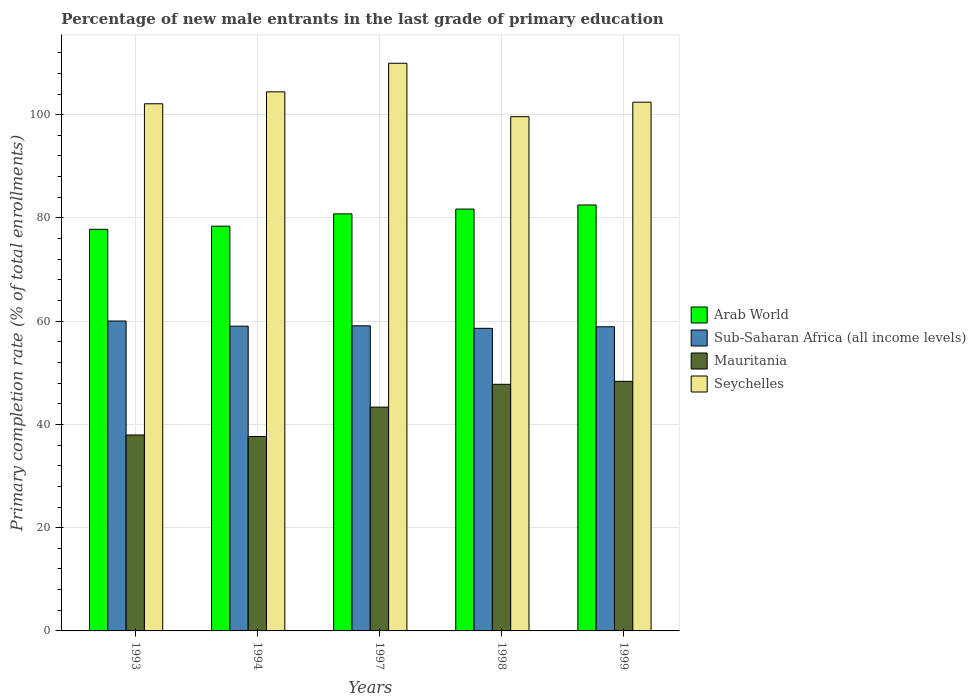How many different coloured bars are there?
Your answer should be very brief. 4. How many groups of bars are there?
Give a very brief answer. 5. Are the number of bars on each tick of the X-axis equal?
Ensure brevity in your answer.  Yes. In how many cases, is the number of bars for a given year not equal to the number of legend labels?
Your answer should be compact. 0. What is the percentage of new male entrants in Sub-Saharan Africa (all income levels) in 1994?
Keep it short and to the point. 59.03. Across all years, what is the maximum percentage of new male entrants in Sub-Saharan Africa (all income levels)?
Your answer should be compact. 60.03. Across all years, what is the minimum percentage of new male entrants in Arab World?
Your answer should be very brief. 77.8. In which year was the percentage of new male entrants in Seychelles maximum?
Ensure brevity in your answer.  1997. In which year was the percentage of new male entrants in Mauritania minimum?
Your response must be concise. 1994. What is the total percentage of new male entrants in Seychelles in the graph?
Keep it short and to the point. 518.54. What is the difference between the percentage of new male entrants in Seychelles in 1993 and that in 1998?
Offer a terse response. 2.5. What is the difference between the percentage of new male entrants in Arab World in 1997 and the percentage of new male entrants in Seychelles in 1999?
Give a very brief answer. -21.63. What is the average percentage of new male entrants in Mauritania per year?
Your answer should be very brief. 43.02. In the year 1999, what is the difference between the percentage of new male entrants in Sub-Saharan Africa (all income levels) and percentage of new male entrants in Mauritania?
Offer a very short reply. 10.57. In how many years, is the percentage of new male entrants in Sub-Saharan Africa (all income levels) greater than 108 %?
Make the answer very short. 0. What is the ratio of the percentage of new male entrants in Mauritania in 1993 to that in 1999?
Your answer should be compact. 0.79. Is the percentage of new male entrants in Arab World in 1993 less than that in 1997?
Offer a terse response. Yes. Is the difference between the percentage of new male entrants in Sub-Saharan Africa (all income levels) in 1993 and 1999 greater than the difference between the percentage of new male entrants in Mauritania in 1993 and 1999?
Offer a terse response. Yes. What is the difference between the highest and the second highest percentage of new male entrants in Seychelles?
Give a very brief answer. 5.54. What is the difference between the highest and the lowest percentage of new male entrants in Sub-Saharan Africa (all income levels)?
Offer a very short reply. 1.42. In how many years, is the percentage of new male entrants in Arab World greater than the average percentage of new male entrants in Arab World taken over all years?
Your answer should be very brief. 3. Is it the case that in every year, the sum of the percentage of new male entrants in Sub-Saharan Africa (all income levels) and percentage of new male entrants in Arab World is greater than the sum of percentage of new male entrants in Mauritania and percentage of new male entrants in Seychelles?
Provide a short and direct response. Yes. What does the 1st bar from the left in 1998 represents?
Offer a terse response. Arab World. What does the 4th bar from the right in 1994 represents?
Your answer should be very brief. Arab World. How many bars are there?
Your answer should be compact. 20. Are all the bars in the graph horizontal?
Give a very brief answer. No. How many years are there in the graph?
Your answer should be very brief. 5. What is the difference between two consecutive major ticks on the Y-axis?
Keep it short and to the point. 20. Are the values on the major ticks of Y-axis written in scientific E-notation?
Keep it short and to the point. No. Does the graph contain grids?
Provide a succinct answer. Yes. Where does the legend appear in the graph?
Keep it short and to the point. Center right. How many legend labels are there?
Provide a short and direct response. 4. What is the title of the graph?
Keep it short and to the point. Percentage of new male entrants in the last grade of primary education. What is the label or title of the Y-axis?
Ensure brevity in your answer.  Primary completion rate (% of total enrollments). What is the Primary completion rate (% of total enrollments) of Arab World in 1993?
Your response must be concise. 77.8. What is the Primary completion rate (% of total enrollments) of Sub-Saharan Africa (all income levels) in 1993?
Offer a terse response. 60.03. What is the Primary completion rate (% of total enrollments) of Mauritania in 1993?
Ensure brevity in your answer.  37.96. What is the Primary completion rate (% of total enrollments) in Seychelles in 1993?
Your answer should be compact. 102.11. What is the Primary completion rate (% of total enrollments) in Arab World in 1994?
Give a very brief answer. 78.4. What is the Primary completion rate (% of total enrollments) in Sub-Saharan Africa (all income levels) in 1994?
Ensure brevity in your answer.  59.03. What is the Primary completion rate (% of total enrollments) in Mauritania in 1994?
Provide a short and direct response. 37.66. What is the Primary completion rate (% of total enrollments) in Seychelles in 1994?
Your answer should be very brief. 104.42. What is the Primary completion rate (% of total enrollments) of Arab World in 1997?
Ensure brevity in your answer.  80.79. What is the Primary completion rate (% of total enrollments) in Sub-Saharan Africa (all income levels) in 1997?
Your answer should be very brief. 59.1. What is the Primary completion rate (% of total enrollments) in Mauritania in 1997?
Keep it short and to the point. 43.35. What is the Primary completion rate (% of total enrollments) of Seychelles in 1997?
Provide a succinct answer. 109.96. What is the Primary completion rate (% of total enrollments) in Arab World in 1998?
Keep it short and to the point. 81.72. What is the Primary completion rate (% of total enrollments) of Sub-Saharan Africa (all income levels) in 1998?
Offer a terse response. 58.61. What is the Primary completion rate (% of total enrollments) in Mauritania in 1998?
Your response must be concise. 47.77. What is the Primary completion rate (% of total enrollments) of Seychelles in 1998?
Your response must be concise. 99.61. What is the Primary completion rate (% of total enrollments) of Arab World in 1999?
Provide a succinct answer. 82.51. What is the Primary completion rate (% of total enrollments) of Sub-Saharan Africa (all income levels) in 1999?
Offer a very short reply. 58.92. What is the Primary completion rate (% of total enrollments) of Mauritania in 1999?
Keep it short and to the point. 48.35. What is the Primary completion rate (% of total enrollments) in Seychelles in 1999?
Offer a very short reply. 102.42. Across all years, what is the maximum Primary completion rate (% of total enrollments) in Arab World?
Your answer should be compact. 82.51. Across all years, what is the maximum Primary completion rate (% of total enrollments) of Sub-Saharan Africa (all income levels)?
Offer a very short reply. 60.03. Across all years, what is the maximum Primary completion rate (% of total enrollments) in Mauritania?
Your response must be concise. 48.35. Across all years, what is the maximum Primary completion rate (% of total enrollments) in Seychelles?
Your answer should be compact. 109.96. Across all years, what is the minimum Primary completion rate (% of total enrollments) of Arab World?
Ensure brevity in your answer.  77.8. Across all years, what is the minimum Primary completion rate (% of total enrollments) of Sub-Saharan Africa (all income levels)?
Ensure brevity in your answer.  58.61. Across all years, what is the minimum Primary completion rate (% of total enrollments) of Mauritania?
Provide a short and direct response. 37.66. Across all years, what is the minimum Primary completion rate (% of total enrollments) of Seychelles?
Keep it short and to the point. 99.61. What is the total Primary completion rate (% of total enrollments) of Arab World in the graph?
Your answer should be very brief. 401.21. What is the total Primary completion rate (% of total enrollments) in Sub-Saharan Africa (all income levels) in the graph?
Provide a succinct answer. 295.7. What is the total Primary completion rate (% of total enrollments) in Mauritania in the graph?
Offer a very short reply. 215.09. What is the total Primary completion rate (% of total enrollments) in Seychelles in the graph?
Provide a short and direct response. 518.54. What is the difference between the Primary completion rate (% of total enrollments) in Arab World in 1993 and that in 1994?
Make the answer very short. -0.61. What is the difference between the Primary completion rate (% of total enrollments) in Sub-Saharan Africa (all income levels) in 1993 and that in 1994?
Offer a terse response. 1. What is the difference between the Primary completion rate (% of total enrollments) of Mauritania in 1993 and that in 1994?
Offer a terse response. 0.29. What is the difference between the Primary completion rate (% of total enrollments) of Seychelles in 1993 and that in 1994?
Offer a very short reply. -2.31. What is the difference between the Primary completion rate (% of total enrollments) in Arab World in 1993 and that in 1997?
Provide a short and direct response. -2.99. What is the difference between the Primary completion rate (% of total enrollments) in Sub-Saharan Africa (all income levels) in 1993 and that in 1997?
Offer a very short reply. 0.93. What is the difference between the Primary completion rate (% of total enrollments) in Mauritania in 1993 and that in 1997?
Your answer should be very brief. -5.39. What is the difference between the Primary completion rate (% of total enrollments) of Seychelles in 1993 and that in 1997?
Offer a terse response. -7.85. What is the difference between the Primary completion rate (% of total enrollments) in Arab World in 1993 and that in 1998?
Offer a terse response. -3.92. What is the difference between the Primary completion rate (% of total enrollments) in Sub-Saharan Africa (all income levels) in 1993 and that in 1998?
Give a very brief answer. 1.42. What is the difference between the Primary completion rate (% of total enrollments) of Mauritania in 1993 and that in 1998?
Your answer should be compact. -9.82. What is the difference between the Primary completion rate (% of total enrollments) in Arab World in 1993 and that in 1999?
Your answer should be compact. -4.71. What is the difference between the Primary completion rate (% of total enrollments) of Sub-Saharan Africa (all income levels) in 1993 and that in 1999?
Make the answer very short. 1.11. What is the difference between the Primary completion rate (% of total enrollments) of Mauritania in 1993 and that in 1999?
Offer a very short reply. -10.39. What is the difference between the Primary completion rate (% of total enrollments) of Seychelles in 1993 and that in 1999?
Give a very brief answer. -0.31. What is the difference between the Primary completion rate (% of total enrollments) in Arab World in 1994 and that in 1997?
Provide a succinct answer. -2.38. What is the difference between the Primary completion rate (% of total enrollments) of Sub-Saharan Africa (all income levels) in 1994 and that in 1997?
Make the answer very short. -0.07. What is the difference between the Primary completion rate (% of total enrollments) of Mauritania in 1994 and that in 1997?
Offer a very short reply. -5.68. What is the difference between the Primary completion rate (% of total enrollments) of Seychelles in 1994 and that in 1997?
Make the answer very short. -5.54. What is the difference between the Primary completion rate (% of total enrollments) of Arab World in 1994 and that in 1998?
Ensure brevity in your answer.  -3.31. What is the difference between the Primary completion rate (% of total enrollments) of Sub-Saharan Africa (all income levels) in 1994 and that in 1998?
Provide a succinct answer. 0.42. What is the difference between the Primary completion rate (% of total enrollments) in Mauritania in 1994 and that in 1998?
Keep it short and to the point. -10.11. What is the difference between the Primary completion rate (% of total enrollments) of Seychelles in 1994 and that in 1998?
Give a very brief answer. 4.81. What is the difference between the Primary completion rate (% of total enrollments) in Arab World in 1994 and that in 1999?
Provide a short and direct response. -4.11. What is the difference between the Primary completion rate (% of total enrollments) of Sub-Saharan Africa (all income levels) in 1994 and that in 1999?
Your answer should be compact. 0.11. What is the difference between the Primary completion rate (% of total enrollments) of Mauritania in 1994 and that in 1999?
Offer a very short reply. -10.68. What is the difference between the Primary completion rate (% of total enrollments) of Seychelles in 1994 and that in 1999?
Keep it short and to the point. 2. What is the difference between the Primary completion rate (% of total enrollments) of Arab World in 1997 and that in 1998?
Your response must be concise. -0.93. What is the difference between the Primary completion rate (% of total enrollments) in Sub-Saharan Africa (all income levels) in 1997 and that in 1998?
Offer a very short reply. 0.49. What is the difference between the Primary completion rate (% of total enrollments) in Mauritania in 1997 and that in 1998?
Your response must be concise. -4.42. What is the difference between the Primary completion rate (% of total enrollments) of Seychelles in 1997 and that in 1998?
Keep it short and to the point. 10.35. What is the difference between the Primary completion rate (% of total enrollments) of Arab World in 1997 and that in 1999?
Your answer should be compact. -1.72. What is the difference between the Primary completion rate (% of total enrollments) in Sub-Saharan Africa (all income levels) in 1997 and that in 1999?
Offer a very short reply. 0.18. What is the difference between the Primary completion rate (% of total enrollments) in Mauritania in 1997 and that in 1999?
Give a very brief answer. -5. What is the difference between the Primary completion rate (% of total enrollments) of Seychelles in 1997 and that in 1999?
Offer a terse response. 7.54. What is the difference between the Primary completion rate (% of total enrollments) of Arab World in 1998 and that in 1999?
Provide a succinct answer. -0.79. What is the difference between the Primary completion rate (% of total enrollments) in Sub-Saharan Africa (all income levels) in 1998 and that in 1999?
Keep it short and to the point. -0.3. What is the difference between the Primary completion rate (% of total enrollments) in Mauritania in 1998 and that in 1999?
Keep it short and to the point. -0.58. What is the difference between the Primary completion rate (% of total enrollments) in Seychelles in 1998 and that in 1999?
Give a very brief answer. -2.81. What is the difference between the Primary completion rate (% of total enrollments) in Arab World in 1993 and the Primary completion rate (% of total enrollments) in Sub-Saharan Africa (all income levels) in 1994?
Offer a very short reply. 18.76. What is the difference between the Primary completion rate (% of total enrollments) in Arab World in 1993 and the Primary completion rate (% of total enrollments) in Mauritania in 1994?
Provide a short and direct response. 40.13. What is the difference between the Primary completion rate (% of total enrollments) of Arab World in 1993 and the Primary completion rate (% of total enrollments) of Seychelles in 1994?
Offer a very short reply. -26.63. What is the difference between the Primary completion rate (% of total enrollments) of Sub-Saharan Africa (all income levels) in 1993 and the Primary completion rate (% of total enrollments) of Mauritania in 1994?
Make the answer very short. 22.37. What is the difference between the Primary completion rate (% of total enrollments) in Sub-Saharan Africa (all income levels) in 1993 and the Primary completion rate (% of total enrollments) in Seychelles in 1994?
Your answer should be very brief. -44.39. What is the difference between the Primary completion rate (% of total enrollments) in Mauritania in 1993 and the Primary completion rate (% of total enrollments) in Seychelles in 1994?
Offer a terse response. -66.47. What is the difference between the Primary completion rate (% of total enrollments) of Arab World in 1993 and the Primary completion rate (% of total enrollments) of Sub-Saharan Africa (all income levels) in 1997?
Ensure brevity in your answer.  18.7. What is the difference between the Primary completion rate (% of total enrollments) of Arab World in 1993 and the Primary completion rate (% of total enrollments) of Mauritania in 1997?
Give a very brief answer. 34.45. What is the difference between the Primary completion rate (% of total enrollments) of Arab World in 1993 and the Primary completion rate (% of total enrollments) of Seychelles in 1997?
Keep it short and to the point. -32.17. What is the difference between the Primary completion rate (% of total enrollments) of Sub-Saharan Africa (all income levels) in 1993 and the Primary completion rate (% of total enrollments) of Mauritania in 1997?
Offer a terse response. 16.68. What is the difference between the Primary completion rate (% of total enrollments) in Sub-Saharan Africa (all income levels) in 1993 and the Primary completion rate (% of total enrollments) in Seychelles in 1997?
Your answer should be very brief. -49.93. What is the difference between the Primary completion rate (% of total enrollments) of Mauritania in 1993 and the Primary completion rate (% of total enrollments) of Seychelles in 1997?
Keep it short and to the point. -72.01. What is the difference between the Primary completion rate (% of total enrollments) of Arab World in 1993 and the Primary completion rate (% of total enrollments) of Sub-Saharan Africa (all income levels) in 1998?
Offer a very short reply. 19.18. What is the difference between the Primary completion rate (% of total enrollments) in Arab World in 1993 and the Primary completion rate (% of total enrollments) in Mauritania in 1998?
Give a very brief answer. 30.02. What is the difference between the Primary completion rate (% of total enrollments) in Arab World in 1993 and the Primary completion rate (% of total enrollments) in Seychelles in 1998?
Provide a short and direct response. -21.82. What is the difference between the Primary completion rate (% of total enrollments) in Sub-Saharan Africa (all income levels) in 1993 and the Primary completion rate (% of total enrollments) in Mauritania in 1998?
Offer a very short reply. 12.26. What is the difference between the Primary completion rate (% of total enrollments) of Sub-Saharan Africa (all income levels) in 1993 and the Primary completion rate (% of total enrollments) of Seychelles in 1998?
Provide a succinct answer. -39.58. What is the difference between the Primary completion rate (% of total enrollments) in Mauritania in 1993 and the Primary completion rate (% of total enrollments) in Seychelles in 1998?
Ensure brevity in your answer.  -61.66. What is the difference between the Primary completion rate (% of total enrollments) in Arab World in 1993 and the Primary completion rate (% of total enrollments) in Sub-Saharan Africa (all income levels) in 1999?
Your answer should be compact. 18.88. What is the difference between the Primary completion rate (% of total enrollments) in Arab World in 1993 and the Primary completion rate (% of total enrollments) in Mauritania in 1999?
Provide a short and direct response. 29.45. What is the difference between the Primary completion rate (% of total enrollments) in Arab World in 1993 and the Primary completion rate (% of total enrollments) in Seychelles in 1999?
Offer a terse response. -24.62. What is the difference between the Primary completion rate (% of total enrollments) in Sub-Saharan Africa (all income levels) in 1993 and the Primary completion rate (% of total enrollments) in Mauritania in 1999?
Provide a short and direct response. 11.68. What is the difference between the Primary completion rate (% of total enrollments) in Sub-Saharan Africa (all income levels) in 1993 and the Primary completion rate (% of total enrollments) in Seychelles in 1999?
Your answer should be very brief. -42.39. What is the difference between the Primary completion rate (% of total enrollments) of Mauritania in 1993 and the Primary completion rate (% of total enrollments) of Seychelles in 1999?
Your answer should be very brief. -64.46. What is the difference between the Primary completion rate (% of total enrollments) of Arab World in 1994 and the Primary completion rate (% of total enrollments) of Sub-Saharan Africa (all income levels) in 1997?
Your answer should be very brief. 19.3. What is the difference between the Primary completion rate (% of total enrollments) of Arab World in 1994 and the Primary completion rate (% of total enrollments) of Mauritania in 1997?
Make the answer very short. 35.05. What is the difference between the Primary completion rate (% of total enrollments) in Arab World in 1994 and the Primary completion rate (% of total enrollments) in Seychelles in 1997?
Provide a succinct answer. -31.56. What is the difference between the Primary completion rate (% of total enrollments) of Sub-Saharan Africa (all income levels) in 1994 and the Primary completion rate (% of total enrollments) of Mauritania in 1997?
Make the answer very short. 15.68. What is the difference between the Primary completion rate (% of total enrollments) of Sub-Saharan Africa (all income levels) in 1994 and the Primary completion rate (% of total enrollments) of Seychelles in 1997?
Offer a very short reply. -50.93. What is the difference between the Primary completion rate (% of total enrollments) in Mauritania in 1994 and the Primary completion rate (% of total enrollments) in Seychelles in 1997?
Provide a succinct answer. -72.3. What is the difference between the Primary completion rate (% of total enrollments) in Arab World in 1994 and the Primary completion rate (% of total enrollments) in Sub-Saharan Africa (all income levels) in 1998?
Your response must be concise. 19.79. What is the difference between the Primary completion rate (% of total enrollments) of Arab World in 1994 and the Primary completion rate (% of total enrollments) of Mauritania in 1998?
Ensure brevity in your answer.  30.63. What is the difference between the Primary completion rate (% of total enrollments) in Arab World in 1994 and the Primary completion rate (% of total enrollments) in Seychelles in 1998?
Your response must be concise. -21.21. What is the difference between the Primary completion rate (% of total enrollments) of Sub-Saharan Africa (all income levels) in 1994 and the Primary completion rate (% of total enrollments) of Mauritania in 1998?
Your response must be concise. 11.26. What is the difference between the Primary completion rate (% of total enrollments) of Sub-Saharan Africa (all income levels) in 1994 and the Primary completion rate (% of total enrollments) of Seychelles in 1998?
Keep it short and to the point. -40.58. What is the difference between the Primary completion rate (% of total enrollments) in Mauritania in 1994 and the Primary completion rate (% of total enrollments) in Seychelles in 1998?
Your answer should be compact. -61.95. What is the difference between the Primary completion rate (% of total enrollments) in Arab World in 1994 and the Primary completion rate (% of total enrollments) in Sub-Saharan Africa (all income levels) in 1999?
Provide a succinct answer. 19.48. What is the difference between the Primary completion rate (% of total enrollments) in Arab World in 1994 and the Primary completion rate (% of total enrollments) in Mauritania in 1999?
Offer a very short reply. 30.05. What is the difference between the Primary completion rate (% of total enrollments) in Arab World in 1994 and the Primary completion rate (% of total enrollments) in Seychelles in 1999?
Give a very brief answer. -24.02. What is the difference between the Primary completion rate (% of total enrollments) in Sub-Saharan Africa (all income levels) in 1994 and the Primary completion rate (% of total enrollments) in Mauritania in 1999?
Offer a terse response. 10.69. What is the difference between the Primary completion rate (% of total enrollments) of Sub-Saharan Africa (all income levels) in 1994 and the Primary completion rate (% of total enrollments) of Seychelles in 1999?
Give a very brief answer. -43.39. What is the difference between the Primary completion rate (% of total enrollments) of Mauritania in 1994 and the Primary completion rate (% of total enrollments) of Seychelles in 1999?
Offer a very short reply. -64.76. What is the difference between the Primary completion rate (% of total enrollments) of Arab World in 1997 and the Primary completion rate (% of total enrollments) of Sub-Saharan Africa (all income levels) in 1998?
Offer a terse response. 22.17. What is the difference between the Primary completion rate (% of total enrollments) of Arab World in 1997 and the Primary completion rate (% of total enrollments) of Mauritania in 1998?
Provide a succinct answer. 33.01. What is the difference between the Primary completion rate (% of total enrollments) of Arab World in 1997 and the Primary completion rate (% of total enrollments) of Seychelles in 1998?
Offer a very short reply. -18.83. What is the difference between the Primary completion rate (% of total enrollments) of Sub-Saharan Africa (all income levels) in 1997 and the Primary completion rate (% of total enrollments) of Mauritania in 1998?
Give a very brief answer. 11.33. What is the difference between the Primary completion rate (% of total enrollments) in Sub-Saharan Africa (all income levels) in 1997 and the Primary completion rate (% of total enrollments) in Seychelles in 1998?
Provide a succinct answer. -40.51. What is the difference between the Primary completion rate (% of total enrollments) in Mauritania in 1997 and the Primary completion rate (% of total enrollments) in Seychelles in 1998?
Your answer should be compact. -56.27. What is the difference between the Primary completion rate (% of total enrollments) of Arab World in 1997 and the Primary completion rate (% of total enrollments) of Sub-Saharan Africa (all income levels) in 1999?
Your response must be concise. 21.87. What is the difference between the Primary completion rate (% of total enrollments) of Arab World in 1997 and the Primary completion rate (% of total enrollments) of Mauritania in 1999?
Your answer should be very brief. 32.44. What is the difference between the Primary completion rate (% of total enrollments) in Arab World in 1997 and the Primary completion rate (% of total enrollments) in Seychelles in 1999?
Keep it short and to the point. -21.63. What is the difference between the Primary completion rate (% of total enrollments) in Sub-Saharan Africa (all income levels) in 1997 and the Primary completion rate (% of total enrollments) in Mauritania in 1999?
Keep it short and to the point. 10.75. What is the difference between the Primary completion rate (% of total enrollments) in Sub-Saharan Africa (all income levels) in 1997 and the Primary completion rate (% of total enrollments) in Seychelles in 1999?
Offer a terse response. -43.32. What is the difference between the Primary completion rate (% of total enrollments) in Mauritania in 1997 and the Primary completion rate (% of total enrollments) in Seychelles in 1999?
Give a very brief answer. -59.07. What is the difference between the Primary completion rate (% of total enrollments) of Arab World in 1998 and the Primary completion rate (% of total enrollments) of Sub-Saharan Africa (all income levels) in 1999?
Make the answer very short. 22.8. What is the difference between the Primary completion rate (% of total enrollments) in Arab World in 1998 and the Primary completion rate (% of total enrollments) in Mauritania in 1999?
Provide a succinct answer. 33.37. What is the difference between the Primary completion rate (% of total enrollments) in Arab World in 1998 and the Primary completion rate (% of total enrollments) in Seychelles in 1999?
Your answer should be very brief. -20.7. What is the difference between the Primary completion rate (% of total enrollments) of Sub-Saharan Africa (all income levels) in 1998 and the Primary completion rate (% of total enrollments) of Mauritania in 1999?
Give a very brief answer. 10.27. What is the difference between the Primary completion rate (% of total enrollments) of Sub-Saharan Africa (all income levels) in 1998 and the Primary completion rate (% of total enrollments) of Seychelles in 1999?
Offer a very short reply. -43.81. What is the difference between the Primary completion rate (% of total enrollments) of Mauritania in 1998 and the Primary completion rate (% of total enrollments) of Seychelles in 1999?
Your answer should be compact. -54.65. What is the average Primary completion rate (% of total enrollments) of Arab World per year?
Keep it short and to the point. 80.24. What is the average Primary completion rate (% of total enrollments) in Sub-Saharan Africa (all income levels) per year?
Your response must be concise. 59.14. What is the average Primary completion rate (% of total enrollments) in Mauritania per year?
Provide a succinct answer. 43.02. What is the average Primary completion rate (% of total enrollments) of Seychelles per year?
Your answer should be compact. 103.71. In the year 1993, what is the difference between the Primary completion rate (% of total enrollments) in Arab World and Primary completion rate (% of total enrollments) in Sub-Saharan Africa (all income levels)?
Your response must be concise. 17.77. In the year 1993, what is the difference between the Primary completion rate (% of total enrollments) of Arab World and Primary completion rate (% of total enrollments) of Mauritania?
Provide a short and direct response. 39.84. In the year 1993, what is the difference between the Primary completion rate (% of total enrollments) of Arab World and Primary completion rate (% of total enrollments) of Seychelles?
Make the answer very short. -24.32. In the year 1993, what is the difference between the Primary completion rate (% of total enrollments) of Sub-Saharan Africa (all income levels) and Primary completion rate (% of total enrollments) of Mauritania?
Ensure brevity in your answer.  22.07. In the year 1993, what is the difference between the Primary completion rate (% of total enrollments) in Sub-Saharan Africa (all income levels) and Primary completion rate (% of total enrollments) in Seychelles?
Offer a terse response. -42.08. In the year 1993, what is the difference between the Primary completion rate (% of total enrollments) in Mauritania and Primary completion rate (% of total enrollments) in Seychelles?
Ensure brevity in your answer.  -64.16. In the year 1994, what is the difference between the Primary completion rate (% of total enrollments) in Arab World and Primary completion rate (% of total enrollments) in Sub-Saharan Africa (all income levels)?
Provide a short and direct response. 19.37. In the year 1994, what is the difference between the Primary completion rate (% of total enrollments) of Arab World and Primary completion rate (% of total enrollments) of Mauritania?
Your response must be concise. 40.74. In the year 1994, what is the difference between the Primary completion rate (% of total enrollments) of Arab World and Primary completion rate (% of total enrollments) of Seychelles?
Make the answer very short. -26.02. In the year 1994, what is the difference between the Primary completion rate (% of total enrollments) of Sub-Saharan Africa (all income levels) and Primary completion rate (% of total enrollments) of Mauritania?
Make the answer very short. 21.37. In the year 1994, what is the difference between the Primary completion rate (% of total enrollments) in Sub-Saharan Africa (all income levels) and Primary completion rate (% of total enrollments) in Seychelles?
Offer a terse response. -45.39. In the year 1994, what is the difference between the Primary completion rate (% of total enrollments) of Mauritania and Primary completion rate (% of total enrollments) of Seychelles?
Make the answer very short. -66.76. In the year 1997, what is the difference between the Primary completion rate (% of total enrollments) of Arab World and Primary completion rate (% of total enrollments) of Sub-Saharan Africa (all income levels)?
Provide a succinct answer. 21.68. In the year 1997, what is the difference between the Primary completion rate (% of total enrollments) in Arab World and Primary completion rate (% of total enrollments) in Mauritania?
Give a very brief answer. 37.44. In the year 1997, what is the difference between the Primary completion rate (% of total enrollments) in Arab World and Primary completion rate (% of total enrollments) in Seychelles?
Give a very brief answer. -29.18. In the year 1997, what is the difference between the Primary completion rate (% of total enrollments) in Sub-Saharan Africa (all income levels) and Primary completion rate (% of total enrollments) in Mauritania?
Offer a terse response. 15.75. In the year 1997, what is the difference between the Primary completion rate (% of total enrollments) in Sub-Saharan Africa (all income levels) and Primary completion rate (% of total enrollments) in Seychelles?
Offer a very short reply. -50.86. In the year 1997, what is the difference between the Primary completion rate (% of total enrollments) in Mauritania and Primary completion rate (% of total enrollments) in Seychelles?
Give a very brief answer. -66.61. In the year 1998, what is the difference between the Primary completion rate (% of total enrollments) of Arab World and Primary completion rate (% of total enrollments) of Sub-Saharan Africa (all income levels)?
Ensure brevity in your answer.  23.1. In the year 1998, what is the difference between the Primary completion rate (% of total enrollments) of Arab World and Primary completion rate (% of total enrollments) of Mauritania?
Offer a terse response. 33.94. In the year 1998, what is the difference between the Primary completion rate (% of total enrollments) in Arab World and Primary completion rate (% of total enrollments) in Seychelles?
Keep it short and to the point. -17.9. In the year 1998, what is the difference between the Primary completion rate (% of total enrollments) of Sub-Saharan Africa (all income levels) and Primary completion rate (% of total enrollments) of Mauritania?
Your response must be concise. 10.84. In the year 1998, what is the difference between the Primary completion rate (% of total enrollments) in Sub-Saharan Africa (all income levels) and Primary completion rate (% of total enrollments) in Seychelles?
Offer a very short reply. -41. In the year 1998, what is the difference between the Primary completion rate (% of total enrollments) of Mauritania and Primary completion rate (% of total enrollments) of Seychelles?
Your response must be concise. -51.84. In the year 1999, what is the difference between the Primary completion rate (% of total enrollments) of Arab World and Primary completion rate (% of total enrollments) of Sub-Saharan Africa (all income levels)?
Offer a very short reply. 23.59. In the year 1999, what is the difference between the Primary completion rate (% of total enrollments) of Arab World and Primary completion rate (% of total enrollments) of Mauritania?
Keep it short and to the point. 34.16. In the year 1999, what is the difference between the Primary completion rate (% of total enrollments) in Arab World and Primary completion rate (% of total enrollments) in Seychelles?
Offer a terse response. -19.91. In the year 1999, what is the difference between the Primary completion rate (% of total enrollments) of Sub-Saharan Africa (all income levels) and Primary completion rate (% of total enrollments) of Mauritania?
Provide a succinct answer. 10.57. In the year 1999, what is the difference between the Primary completion rate (% of total enrollments) of Sub-Saharan Africa (all income levels) and Primary completion rate (% of total enrollments) of Seychelles?
Your response must be concise. -43.5. In the year 1999, what is the difference between the Primary completion rate (% of total enrollments) in Mauritania and Primary completion rate (% of total enrollments) in Seychelles?
Give a very brief answer. -54.07. What is the ratio of the Primary completion rate (% of total enrollments) of Sub-Saharan Africa (all income levels) in 1993 to that in 1994?
Your answer should be compact. 1.02. What is the ratio of the Primary completion rate (% of total enrollments) of Mauritania in 1993 to that in 1994?
Your response must be concise. 1.01. What is the ratio of the Primary completion rate (% of total enrollments) of Seychelles in 1993 to that in 1994?
Keep it short and to the point. 0.98. What is the ratio of the Primary completion rate (% of total enrollments) in Arab World in 1993 to that in 1997?
Provide a short and direct response. 0.96. What is the ratio of the Primary completion rate (% of total enrollments) of Sub-Saharan Africa (all income levels) in 1993 to that in 1997?
Your answer should be very brief. 1.02. What is the ratio of the Primary completion rate (% of total enrollments) of Mauritania in 1993 to that in 1997?
Your answer should be compact. 0.88. What is the ratio of the Primary completion rate (% of total enrollments) of Seychelles in 1993 to that in 1997?
Offer a terse response. 0.93. What is the ratio of the Primary completion rate (% of total enrollments) in Sub-Saharan Africa (all income levels) in 1993 to that in 1998?
Your response must be concise. 1.02. What is the ratio of the Primary completion rate (% of total enrollments) of Mauritania in 1993 to that in 1998?
Ensure brevity in your answer.  0.79. What is the ratio of the Primary completion rate (% of total enrollments) in Seychelles in 1993 to that in 1998?
Your response must be concise. 1.03. What is the ratio of the Primary completion rate (% of total enrollments) in Arab World in 1993 to that in 1999?
Provide a succinct answer. 0.94. What is the ratio of the Primary completion rate (% of total enrollments) in Sub-Saharan Africa (all income levels) in 1993 to that in 1999?
Offer a very short reply. 1.02. What is the ratio of the Primary completion rate (% of total enrollments) in Mauritania in 1993 to that in 1999?
Your answer should be compact. 0.79. What is the ratio of the Primary completion rate (% of total enrollments) of Seychelles in 1993 to that in 1999?
Keep it short and to the point. 1. What is the ratio of the Primary completion rate (% of total enrollments) of Arab World in 1994 to that in 1997?
Make the answer very short. 0.97. What is the ratio of the Primary completion rate (% of total enrollments) in Mauritania in 1994 to that in 1997?
Your response must be concise. 0.87. What is the ratio of the Primary completion rate (% of total enrollments) in Seychelles in 1994 to that in 1997?
Provide a succinct answer. 0.95. What is the ratio of the Primary completion rate (% of total enrollments) in Arab World in 1994 to that in 1998?
Keep it short and to the point. 0.96. What is the ratio of the Primary completion rate (% of total enrollments) of Sub-Saharan Africa (all income levels) in 1994 to that in 1998?
Keep it short and to the point. 1.01. What is the ratio of the Primary completion rate (% of total enrollments) of Mauritania in 1994 to that in 1998?
Ensure brevity in your answer.  0.79. What is the ratio of the Primary completion rate (% of total enrollments) of Seychelles in 1994 to that in 1998?
Offer a terse response. 1.05. What is the ratio of the Primary completion rate (% of total enrollments) of Arab World in 1994 to that in 1999?
Provide a succinct answer. 0.95. What is the ratio of the Primary completion rate (% of total enrollments) of Sub-Saharan Africa (all income levels) in 1994 to that in 1999?
Give a very brief answer. 1. What is the ratio of the Primary completion rate (% of total enrollments) of Mauritania in 1994 to that in 1999?
Give a very brief answer. 0.78. What is the ratio of the Primary completion rate (% of total enrollments) of Seychelles in 1994 to that in 1999?
Provide a succinct answer. 1.02. What is the ratio of the Primary completion rate (% of total enrollments) in Arab World in 1997 to that in 1998?
Your answer should be very brief. 0.99. What is the ratio of the Primary completion rate (% of total enrollments) in Sub-Saharan Africa (all income levels) in 1997 to that in 1998?
Give a very brief answer. 1.01. What is the ratio of the Primary completion rate (% of total enrollments) in Mauritania in 1997 to that in 1998?
Ensure brevity in your answer.  0.91. What is the ratio of the Primary completion rate (% of total enrollments) of Seychelles in 1997 to that in 1998?
Give a very brief answer. 1.1. What is the ratio of the Primary completion rate (% of total enrollments) of Arab World in 1997 to that in 1999?
Provide a succinct answer. 0.98. What is the ratio of the Primary completion rate (% of total enrollments) in Sub-Saharan Africa (all income levels) in 1997 to that in 1999?
Give a very brief answer. 1. What is the ratio of the Primary completion rate (% of total enrollments) in Mauritania in 1997 to that in 1999?
Provide a short and direct response. 0.9. What is the ratio of the Primary completion rate (% of total enrollments) of Seychelles in 1997 to that in 1999?
Keep it short and to the point. 1.07. What is the ratio of the Primary completion rate (% of total enrollments) of Mauritania in 1998 to that in 1999?
Give a very brief answer. 0.99. What is the ratio of the Primary completion rate (% of total enrollments) of Seychelles in 1998 to that in 1999?
Offer a terse response. 0.97. What is the difference between the highest and the second highest Primary completion rate (% of total enrollments) in Arab World?
Offer a terse response. 0.79. What is the difference between the highest and the second highest Primary completion rate (% of total enrollments) in Sub-Saharan Africa (all income levels)?
Keep it short and to the point. 0.93. What is the difference between the highest and the second highest Primary completion rate (% of total enrollments) in Mauritania?
Your response must be concise. 0.58. What is the difference between the highest and the second highest Primary completion rate (% of total enrollments) in Seychelles?
Offer a very short reply. 5.54. What is the difference between the highest and the lowest Primary completion rate (% of total enrollments) of Arab World?
Give a very brief answer. 4.71. What is the difference between the highest and the lowest Primary completion rate (% of total enrollments) in Sub-Saharan Africa (all income levels)?
Your response must be concise. 1.42. What is the difference between the highest and the lowest Primary completion rate (% of total enrollments) in Mauritania?
Your answer should be very brief. 10.68. What is the difference between the highest and the lowest Primary completion rate (% of total enrollments) in Seychelles?
Your answer should be very brief. 10.35. 